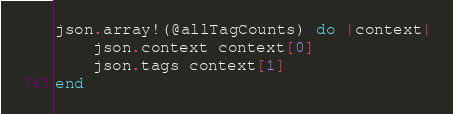<code> <loc_0><loc_0><loc_500><loc_500><_Ruby_>
json.array!(@allTagCounts) do |context|
    json.context context[0]
    json.tags context[1]
end
</code> 